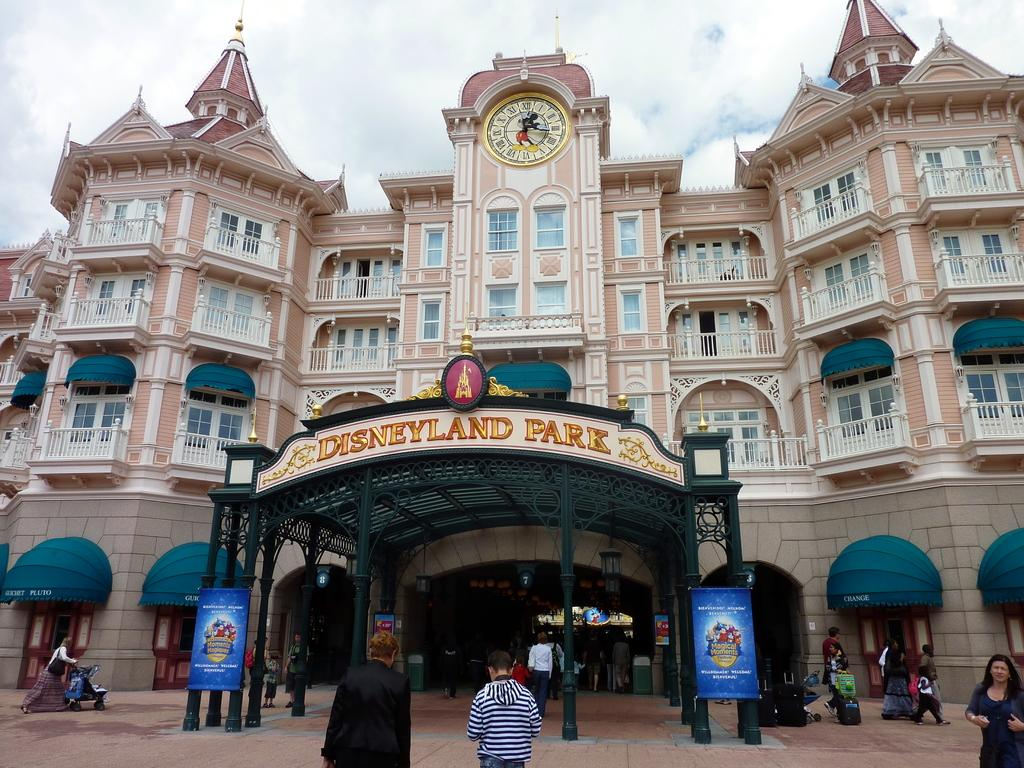What type of structure is visible in the image? There is a building in the image. What time-telling device is present in the image? There is a clock present in the image. What architectural feature can be seen at the bottom of the image? There is an arch at the bottom of the image. What is located at the bottom of the image, next to the arch? There is a board at the bottom of the image. What can be seen on the road in the image? There are people on the road in the image. What vertical structures are visible in the image? There are poles visible in the image. What is visible at the top of the image? The sky is visible at the top of the image. What type of lace is being used to decorate the building in the image? There is no lace present in the image; it is a building with an arch, a clock, and a board at the bottom, along with poles and people on the road. Who is the porter in the image, and what is their role? There is no porter present in the image; it features a building, a clock, an arch, a board, poles, and people on the road. 